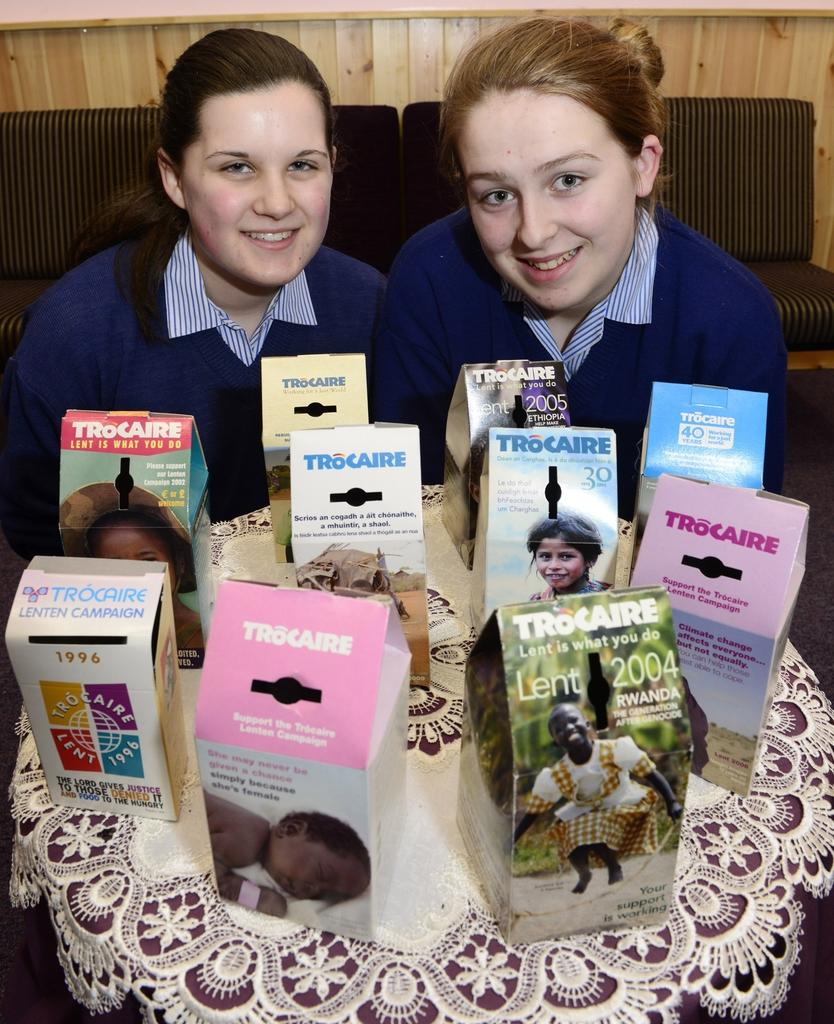How many people are in the image? There are two women in the image. What is the facial expression of the women? Both women are smiling. What objects can be seen on the table in front of the women? There are boxes on the table in front of the women. What type of jelly is being used to decorate the women's tongues in the image? There is no jelly or any decoration on the women's tongues in the image. Can you tell me how many gravestones are visible in the cemetery in the image? There is no cemetery or gravestones present in the image; it features two women smiling in front of a table with boxes. 